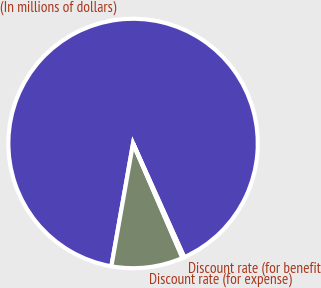Convert chart. <chart><loc_0><loc_0><loc_500><loc_500><pie_chart><fcel>(In millions of dollars)<fcel>Discount rate (for expense)<fcel>Discount rate (for benefit<nl><fcel>90.49%<fcel>9.27%<fcel>0.24%<nl></chart> 